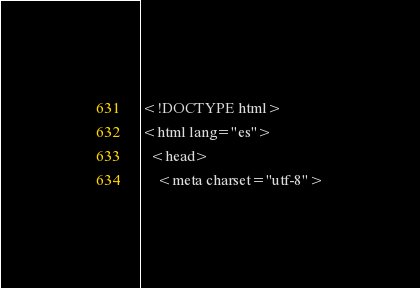Convert code to text. <code><loc_0><loc_0><loc_500><loc_500><_PHP_><!DOCTYPE html>
<html lang="es">
  <head>
    <meta charset="utf-8"></code> 